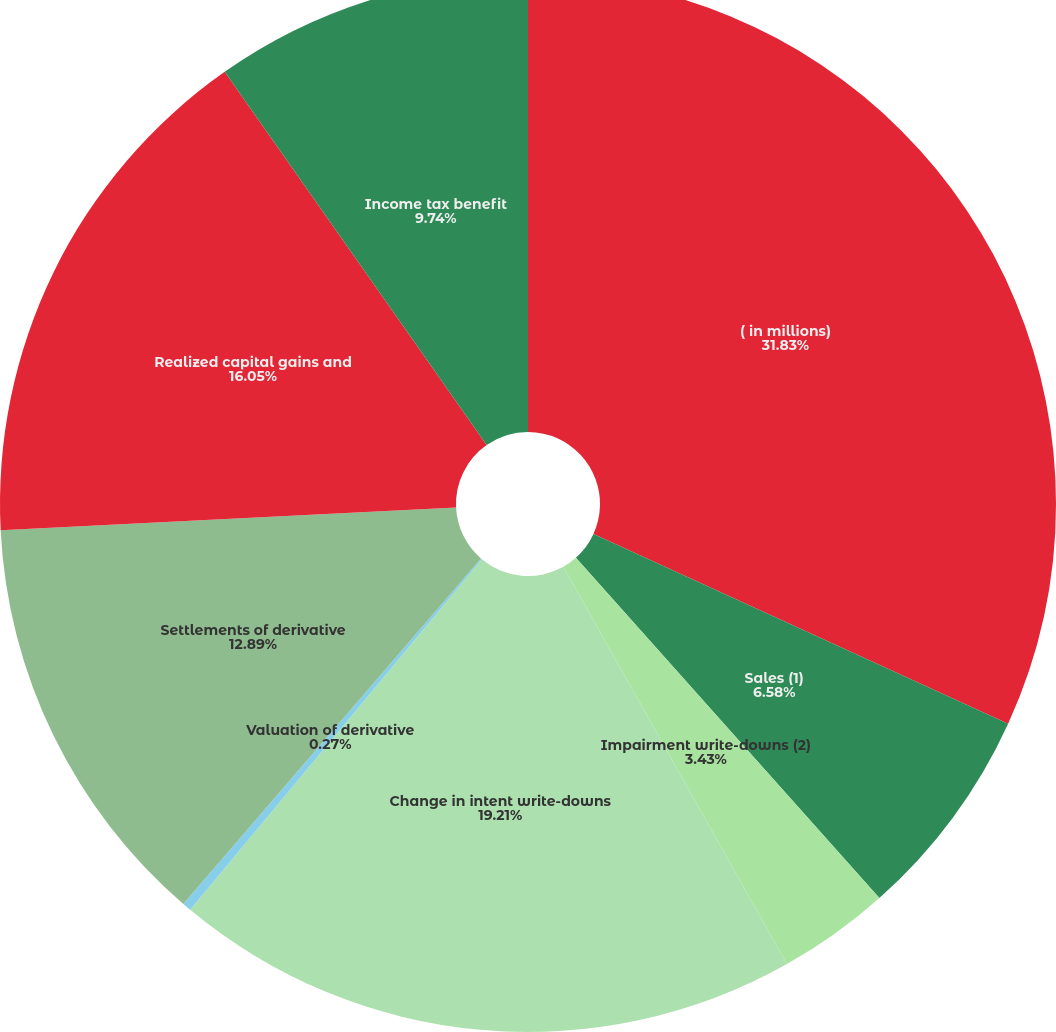Convert chart. <chart><loc_0><loc_0><loc_500><loc_500><pie_chart><fcel>( in millions)<fcel>Sales (1)<fcel>Impairment write-downs (2)<fcel>Change in intent write-downs<fcel>Valuation of derivative<fcel>Settlements of derivative<fcel>Realized capital gains and<fcel>Income tax benefit<nl><fcel>31.83%<fcel>6.58%<fcel>3.43%<fcel>19.21%<fcel>0.27%<fcel>12.89%<fcel>16.05%<fcel>9.74%<nl></chart> 